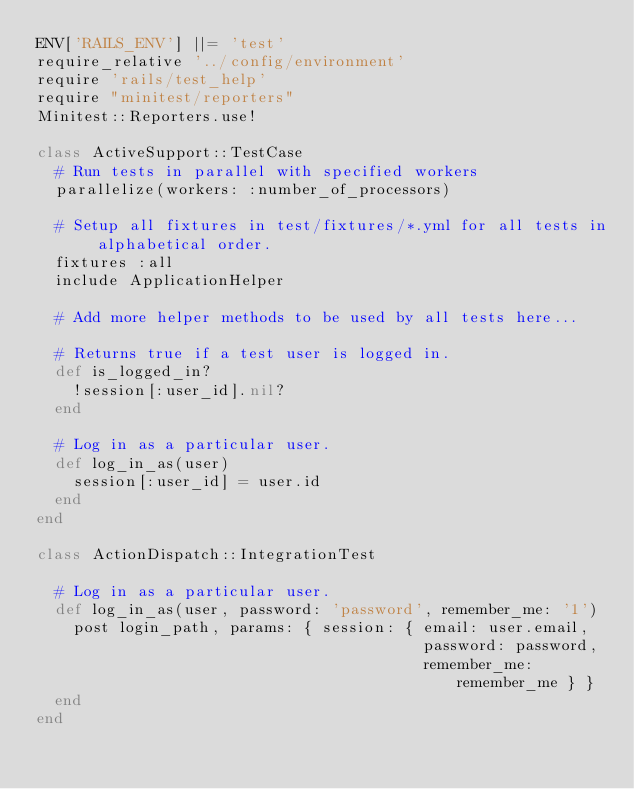<code> <loc_0><loc_0><loc_500><loc_500><_Ruby_>ENV['RAILS_ENV'] ||= 'test'
require_relative '../config/environment'
require 'rails/test_help'
require "minitest/reporters"
Minitest::Reporters.use!

class ActiveSupport::TestCase
  # Run tests in parallel with specified workers
  parallelize(workers: :number_of_processors)

  # Setup all fixtures in test/fixtures/*.yml for all tests in alphabetical order.
  fixtures :all
  include ApplicationHelper

  # Add more helper methods to be used by all tests here...
  
  # Returns true if a test user is logged in.
  def is_logged_in?
    !session[:user_id].nil?
  end
  
  # Log in as a particular user.
  def log_in_as(user)
    session[:user_id] = user.id
  end
end

class ActionDispatch::IntegrationTest

  # Log in as a particular user.
  def log_in_as(user, password: 'password', remember_me: '1')
    post login_path, params: { session: { email: user.email,
                                          password: password,
                                          remember_me: remember_me } }
  end
end</code> 